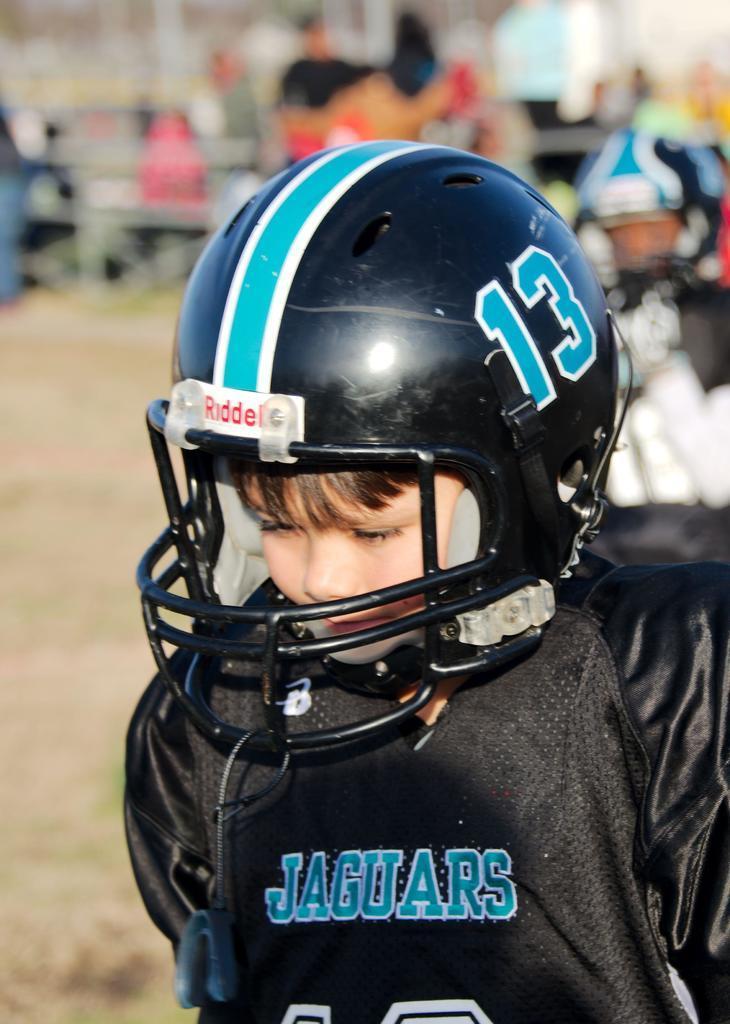Could you give a brief overview of what you see in this image? In this image I can see a boy in black colour dress. I can see he is wearing a helmet and I can see something is written at few places. In the background I can see few people and I can see this image is little bit blurry from background. 